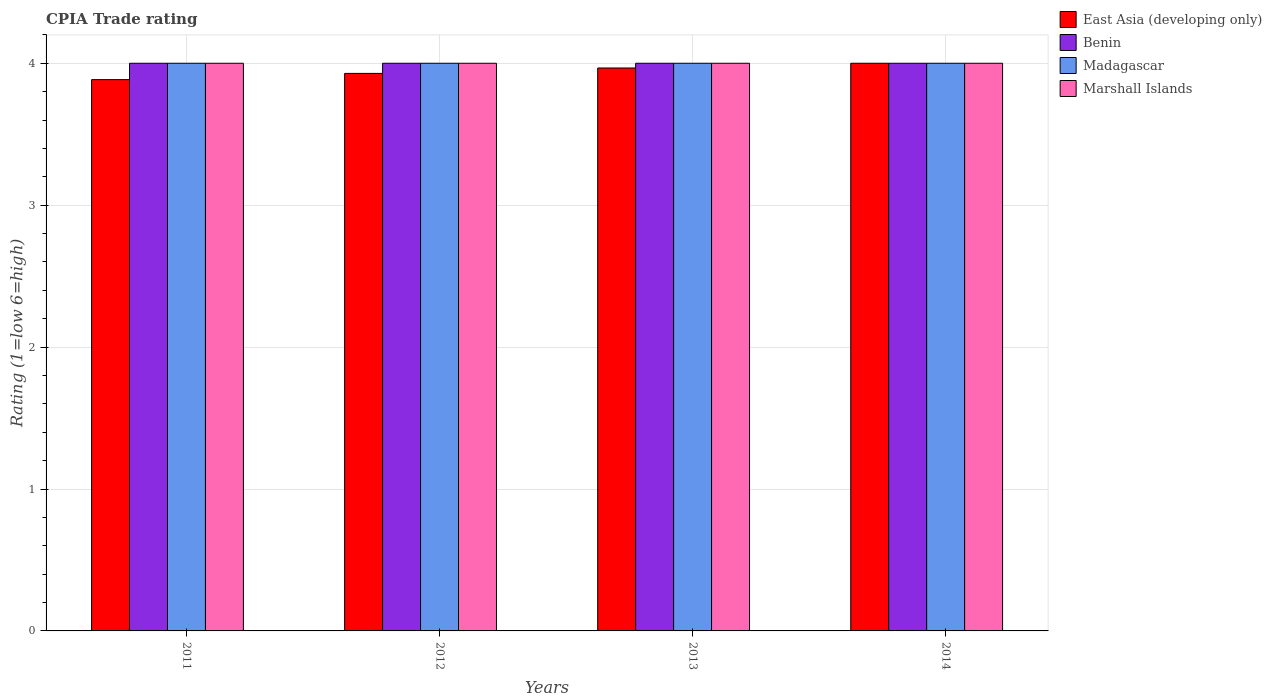How many different coloured bars are there?
Provide a short and direct response. 4. Are the number of bars per tick equal to the number of legend labels?
Give a very brief answer. Yes. Are the number of bars on each tick of the X-axis equal?
Offer a terse response. Yes. How many bars are there on the 1st tick from the left?
Provide a succinct answer. 4. How many bars are there on the 2nd tick from the right?
Ensure brevity in your answer.  4. What is the label of the 3rd group of bars from the left?
Keep it short and to the point. 2013. In how many cases, is the number of bars for a given year not equal to the number of legend labels?
Ensure brevity in your answer.  0. What is the CPIA rating in Madagascar in 2014?
Make the answer very short. 4. Across all years, what is the maximum CPIA rating in East Asia (developing only)?
Offer a very short reply. 4. In which year was the CPIA rating in East Asia (developing only) maximum?
Offer a terse response. 2014. In which year was the CPIA rating in Benin minimum?
Give a very brief answer. 2011. What is the total CPIA rating in Benin in the graph?
Your answer should be compact. 16. In the year 2012, what is the difference between the CPIA rating in Benin and CPIA rating in East Asia (developing only)?
Keep it short and to the point. 0.07. Is the CPIA rating in Benin in 2011 less than that in 2014?
Your answer should be compact. No. What is the difference between the highest and the second highest CPIA rating in Marshall Islands?
Make the answer very short. 0. In how many years, is the CPIA rating in Marshall Islands greater than the average CPIA rating in Marshall Islands taken over all years?
Give a very brief answer. 0. Is the sum of the CPIA rating in Marshall Islands in 2013 and 2014 greater than the maximum CPIA rating in Madagascar across all years?
Keep it short and to the point. Yes. Is it the case that in every year, the sum of the CPIA rating in Madagascar and CPIA rating in Marshall Islands is greater than the sum of CPIA rating in Benin and CPIA rating in East Asia (developing only)?
Your answer should be compact. Yes. What does the 1st bar from the left in 2011 represents?
Offer a very short reply. East Asia (developing only). What does the 3rd bar from the right in 2011 represents?
Keep it short and to the point. Benin. Are all the bars in the graph horizontal?
Your answer should be compact. No. How many years are there in the graph?
Provide a succinct answer. 4. Are the values on the major ticks of Y-axis written in scientific E-notation?
Provide a short and direct response. No. Does the graph contain grids?
Make the answer very short. Yes. Where does the legend appear in the graph?
Provide a short and direct response. Top right. How are the legend labels stacked?
Your response must be concise. Vertical. What is the title of the graph?
Ensure brevity in your answer.  CPIA Trade rating. Does "France" appear as one of the legend labels in the graph?
Make the answer very short. No. What is the label or title of the X-axis?
Offer a very short reply. Years. What is the label or title of the Y-axis?
Make the answer very short. Rating (1=low 6=high). What is the Rating (1=low 6=high) in East Asia (developing only) in 2011?
Provide a succinct answer. 3.88. What is the Rating (1=low 6=high) in Marshall Islands in 2011?
Offer a terse response. 4. What is the Rating (1=low 6=high) in East Asia (developing only) in 2012?
Your answer should be very brief. 3.93. What is the Rating (1=low 6=high) of Benin in 2012?
Provide a short and direct response. 4. What is the Rating (1=low 6=high) in Madagascar in 2012?
Make the answer very short. 4. What is the Rating (1=low 6=high) in East Asia (developing only) in 2013?
Offer a very short reply. 3.97. What is the Rating (1=low 6=high) of Benin in 2014?
Provide a short and direct response. 4. What is the Rating (1=low 6=high) in Marshall Islands in 2014?
Ensure brevity in your answer.  4. Across all years, what is the maximum Rating (1=low 6=high) of Benin?
Provide a succinct answer. 4. Across all years, what is the maximum Rating (1=low 6=high) of Madagascar?
Provide a short and direct response. 4. Across all years, what is the minimum Rating (1=low 6=high) of East Asia (developing only)?
Provide a succinct answer. 3.88. Across all years, what is the minimum Rating (1=low 6=high) of Madagascar?
Offer a terse response. 4. What is the total Rating (1=low 6=high) in East Asia (developing only) in the graph?
Make the answer very short. 15.78. What is the total Rating (1=low 6=high) in Benin in the graph?
Make the answer very short. 16. What is the difference between the Rating (1=low 6=high) in East Asia (developing only) in 2011 and that in 2012?
Your response must be concise. -0.04. What is the difference between the Rating (1=low 6=high) in Marshall Islands in 2011 and that in 2012?
Keep it short and to the point. 0. What is the difference between the Rating (1=low 6=high) of East Asia (developing only) in 2011 and that in 2013?
Make the answer very short. -0.08. What is the difference between the Rating (1=low 6=high) of Madagascar in 2011 and that in 2013?
Give a very brief answer. 0. What is the difference between the Rating (1=low 6=high) of Marshall Islands in 2011 and that in 2013?
Your answer should be very brief. 0. What is the difference between the Rating (1=low 6=high) in East Asia (developing only) in 2011 and that in 2014?
Keep it short and to the point. -0.12. What is the difference between the Rating (1=low 6=high) of Madagascar in 2011 and that in 2014?
Your answer should be very brief. 0. What is the difference between the Rating (1=low 6=high) in Marshall Islands in 2011 and that in 2014?
Your answer should be compact. 0. What is the difference between the Rating (1=low 6=high) in East Asia (developing only) in 2012 and that in 2013?
Your response must be concise. -0.04. What is the difference between the Rating (1=low 6=high) of Marshall Islands in 2012 and that in 2013?
Give a very brief answer. 0. What is the difference between the Rating (1=low 6=high) in East Asia (developing only) in 2012 and that in 2014?
Keep it short and to the point. -0.07. What is the difference between the Rating (1=low 6=high) of Benin in 2012 and that in 2014?
Provide a succinct answer. 0. What is the difference between the Rating (1=low 6=high) in Madagascar in 2012 and that in 2014?
Your response must be concise. 0. What is the difference between the Rating (1=low 6=high) of Marshall Islands in 2012 and that in 2014?
Keep it short and to the point. 0. What is the difference between the Rating (1=low 6=high) of East Asia (developing only) in 2013 and that in 2014?
Provide a succinct answer. -0.03. What is the difference between the Rating (1=low 6=high) in East Asia (developing only) in 2011 and the Rating (1=low 6=high) in Benin in 2012?
Your response must be concise. -0.12. What is the difference between the Rating (1=low 6=high) in East Asia (developing only) in 2011 and the Rating (1=low 6=high) in Madagascar in 2012?
Provide a short and direct response. -0.12. What is the difference between the Rating (1=low 6=high) in East Asia (developing only) in 2011 and the Rating (1=low 6=high) in Marshall Islands in 2012?
Ensure brevity in your answer.  -0.12. What is the difference between the Rating (1=low 6=high) of Benin in 2011 and the Rating (1=low 6=high) of Madagascar in 2012?
Provide a short and direct response. 0. What is the difference between the Rating (1=low 6=high) in Madagascar in 2011 and the Rating (1=low 6=high) in Marshall Islands in 2012?
Your answer should be compact. 0. What is the difference between the Rating (1=low 6=high) of East Asia (developing only) in 2011 and the Rating (1=low 6=high) of Benin in 2013?
Make the answer very short. -0.12. What is the difference between the Rating (1=low 6=high) in East Asia (developing only) in 2011 and the Rating (1=low 6=high) in Madagascar in 2013?
Ensure brevity in your answer.  -0.12. What is the difference between the Rating (1=low 6=high) in East Asia (developing only) in 2011 and the Rating (1=low 6=high) in Marshall Islands in 2013?
Make the answer very short. -0.12. What is the difference between the Rating (1=low 6=high) of Benin in 2011 and the Rating (1=low 6=high) of Madagascar in 2013?
Keep it short and to the point. 0. What is the difference between the Rating (1=low 6=high) in East Asia (developing only) in 2011 and the Rating (1=low 6=high) in Benin in 2014?
Ensure brevity in your answer.  -0.12. What is the difference between the Rating (1=low 6=high) of East Asia (developing only) in 2011 and the Rating (1=low 6=high) of Madagascar in 2014?
Provide a short and direct response. -0.12. What is the difference between the Rating (1=low 6=high) in East Asia (developing only) in 2011 and the Rating (1=low 6=high) in Marshall Islands in 2014?
Ensure brevity in your answer.  -0.12. What is the difference between the Rating (1=low 6=high) in Madagascar in 2011 and the Rating (1=low 6=high) in Marshall Islands in 2014?
Offer a very short reply. 0. What is the difference between the Rating (1=low 6=high) in East Asia (developing only) in 2012 and the Rating (1=low 6=high) in Benin in 2013?
Provide a short and direct response. -0.07. What is the difference between the Rating (1=low 6=high) in East Asia (developing only) in 2012 and the Rating (1=low 6=high) in Madagascar in 2013?
Your answer should be very brief. -0.07. What is the difference between the Rating (1=low 6=high) in East Asia (developing only) in 2012 and the Rating (1=low 6=high) in Marshall Islands in 2013?
Make the answer very short. -0.07. What is the difference between the Rating (1=low 6=high) of Benin in 2012 and the Rating (1=low 6=high) of Madagascar in 2013?
Give a very brief answer. 0. What is the difference between the Rating (1=low 6=high) in Benin in 2012 and the Rating (1=low 6=high) in Marshall Islands in 2013?
Your response must be concise. 0. What is the difference between the Rating (1=low 6=high) of East Asia (developing only) in 2012 and the Rating (1=low 6=high) of Benin in 2014?
Offer a terse response. -0.07. What is the difference between the Rating (1=low 6=high) in East Asia (developing only) in 2012 and the Rating (1=low 6=high) in Madagascar in 2014?
Provide a succinct answer. -0.07. What is the difference between the Rating (1=low 6=high) in East Asia (developing only) in 2012 and the Rating (1=low 6=high) in Marshall Islands in 2014?
Keep it short and to the point. -0.07. What is the difference between the Rating (1=low 6=high) in Madagascar in 2012 and the Rating (1=low 6=high) in Marshall Islands in 2014?
Offer a terse response. 0. What is the difference between the Rating (1=low 6=high) of East Asia (developing only) in 2013 and the Rating (1=low 6=high) of Benin in 2014?
Your answer should be very brief. -0.03. What is the difference between the Rating (1=low 6=high) of East Asia (developing only) in 2013 and the Rating (1=low 6=high) of Madagascar in 2014?
Your answer should be compact. -0.03. What is the difference between the Rating (1=low 6=high) of East Asia (developing only) in 2013 and the Rating (1=low 6=high) of Marshall Islands in 2014?
Ensure brevity in your answer.  -0.03. What is the difference between the Rating (1=low 6=high) of Madagascar in 2013 and the Rating (1=low 6=high) of Marshall Islands in 2014?
Your response must be concise. 0. What is the average Rating (1=low 6=high) in East Asia (developing only) per year?
Offer a very short reply. 3.94. What is the average Rating (1=low 6=high) in Marshall Islands per year?
Make the answer very short. 4. In the year 2011, what is the difference between the Rating (1=low 6=high) of East Asia (developing only) and Rating (1=low 6=high) of Benin?
Make the answer very short. -0.12. In the year 2011, what is the difference between the Rating (1=low 6=high) in East Asia (developing only) and Rating (1=low 6=high) in Madagascar?
Offer a very short reply. -0.12. In the year 2011, what is the difference between the Rating (1=low 6=high) of East Asia (developing only) and Rating (1=low 6=high) of Marshall Islands?
Offer a very short reply. -0.12. In the year 2011, what is the difference between the Rating (1=low 6=high) in Benin and Rating (1=low 6=high) in Marshall Islands?
Your response must be concise. 0. In the year 2012, what is the difference between the Rating (1=low 6=high) in East Asia (developing only) and Rating (1=low 6=high) in Benin?
Your answer should be very brief. -0.07. In the year 2012, what is the difference between the Rating (1=low 6=high) of East Asia (developing only) and Rating (1=low 6=high) of Madagascar?
Provide a short and direct response. -0.07. In the year 2012, what is the difference between the Rating (1=low 6=high) of East Asia (developing only) and Rating (1=low 6=high) of Marshall Islands?
Make the answer very short. -0.07. In the year 2012, what is the difference between the Rating (1=low 6=high) of Madagascar and Rating (1=low 6=high) of Marshall Islands?
Your answer should be compact. 0. In the year 2013, what is the difference between the Rating (1=low 6=high) of East Asia (developing only) and Rating (1=low 6=high) of Benin?
Provide a succinct answer. -0.03. In the year 2013, what is the difference between the Rating (1=low 6=high) of East Asia (developing only) and Rating (1=low 6=high) of Madagascar?
Provide a short and direct response. -0.03. In the year 2013, what is the difference between the Rating (1=low 6=high) of East Asia (developing only) and Rating (1=low 6=high) of Marshall Islands?
Your answer should be very brief. -0.03. In the year 2013, what is the difference between the Rating (1=low 6=high) in Benin and Rating (1=low 6=high) in Madagascar?
Your answer should be compact. 0. In the year 2013, what is the difference between the Rating (1=low 6=high) of Benin and Rating (1=low 6=high) of Marshall Islands?
Ensure brevity in your answer.  0. In the year 2014, what is the difference between the Rating (1=low 6=high) in East Asia (developing only) and Rating (1=low 6=high) in Madagascar?
Give a very brief answer. 0. In the year 2014, what is the difference between the Rating (1=low 6=high) of East Asia (developing only) and Rating (1=low 6=high) of Marshall Islands?
Make the answer very short. 0. In the year 2014, what is the difference between the Rating (1=low 6=high) in Benin and Rating (1=low 6=high) in Madagascar?
Keep it short and to the point. 0. In the year 2014, what is the difference between the Rating (1=low 6=high) of Benin and Rating (1=low 6=high) of Marshall Islands?
Keep it short and to the point. 0. In the year 2014, what is the difference between the Rating (1=low 6=high) of Madagascar and Rating (1=low 6=high) of Marshall Islands?
Your answer should be compact. 0. What is the ratio of the Rating (1=low 6=high) in East Asia (developing only) in 2011 to that in 2012?
Provide a succinct answer. 0.99. What is the ratio of the Rating (1=low 6=high) in Benin in 2011 to that in 2012?
Give a very brief answer. 1. What is the ratio of the Rating (1=low 6=high) in Marshall Islands in 2011 to that in 2012?
Provide a short and direct response. 1. What is the ratio of the Rating (1=low 6=high) of East Asia (developing only) in 2011 to that in 2013?
Ensure brevity in your answer.  0.98. What is the ratio of the Rating (1=low 6=high) of Madagascar in 2011 to that in 2013?
Offer a terse response. 1. What is the ratio of the Rating (1=low 6=high) in Marshall Islands in 2011 to that in 2013?
Offer a very short reply. 1. What is the ratio of the Rating (1=low 6=high) of East Asia (developing only) in 2011 to that in 2014?
Provide a succinct answer. 0.97. What is the ratio of the Rating (1=low 6=high) of Benin in 2011 to that in 2014?
Your answer should be compact. 1. What is the ratio of the Rating (1=low 6=high) in Madagascar in 2011 to that in 2014?
Your answer should be very brief. 1. What is the ratio of the Rating (1=low 6=high) of Marshall Islands in 2011 to that in 2014?
Offer a very short reply. 1. What is the ratio of the Rating (1=low 6=high) in Marshall Islands in 2012 to that in 2013?
Offer a very short reply. 1. What is the ratio of the Rating (1=low 6=high) of East Asia (developing only) in 2012 to that in 2014?
Ensure brevity in your answer.  0.98. What is the ratio of the Rating (1=low 6=high) of Madagascar in 2012 to that in 2014?
Provide a succinct answer. 1. What is the difference between the highest and the second highest Rating (1=low 6=high) in East Asia (developing only)?
Your answer should be compact. 0.03. What is the difference between the highest and the second highest Rating (1=low 6=high) in Benin?
Offer a very short reply. 0. What is the difference between the highest and the lowest Rating (1=low 6=high) of East Asia (developing only)?
Your response must be concise. 0.12. What is the difference between the highest and the lowest Rating (1=low 6=high) of Marshall Islands?
Make the answer very short. 0. 